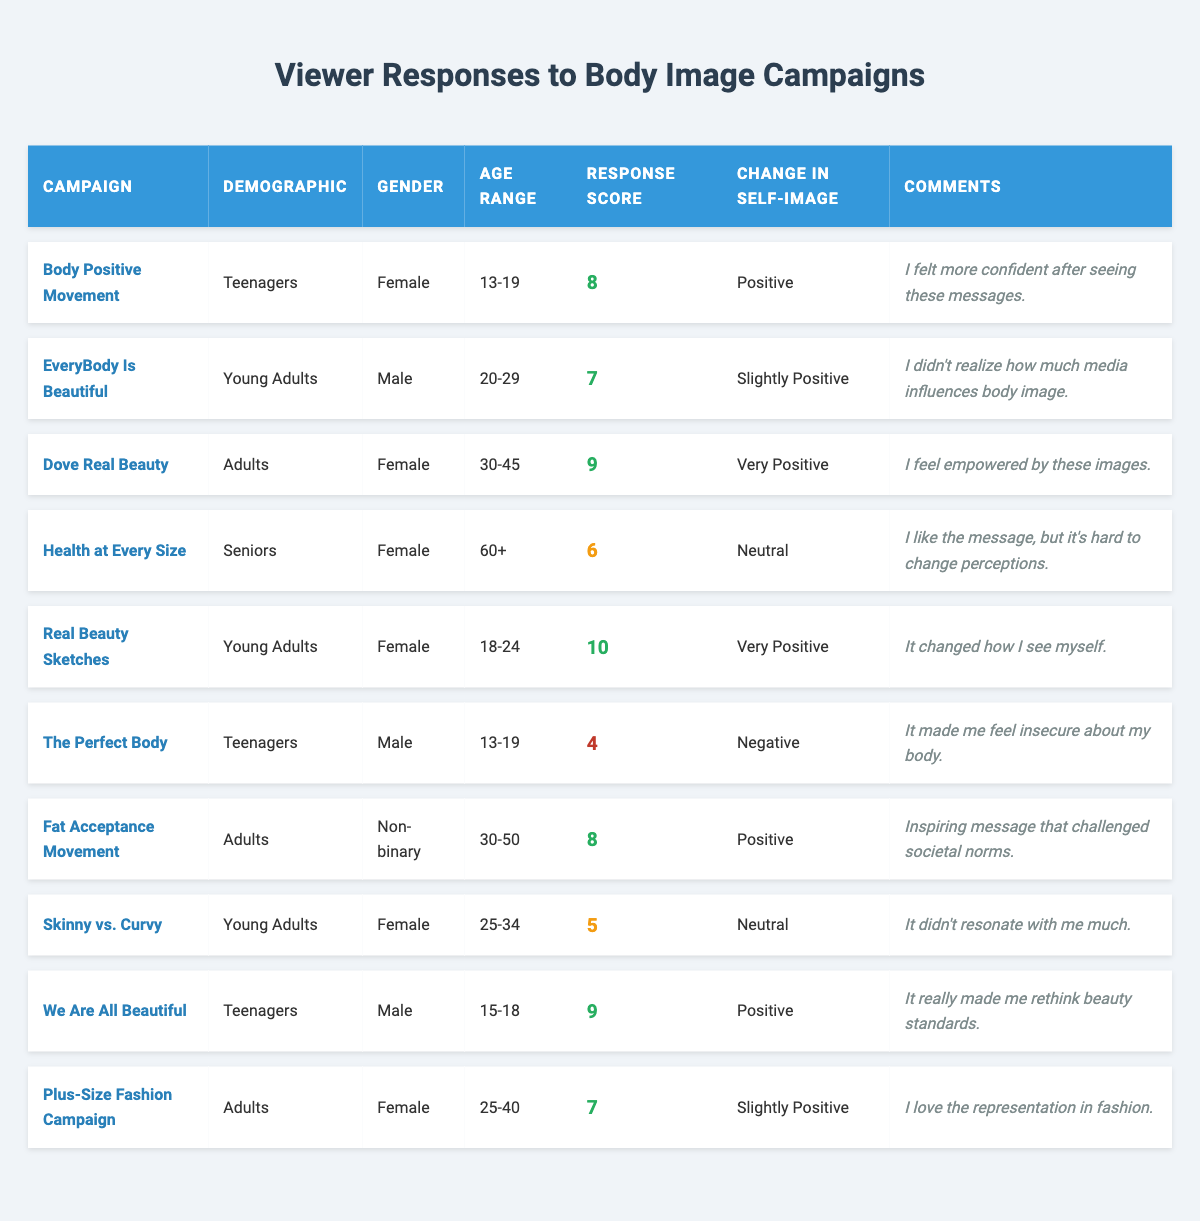What is the response score for the "Dove Real Beauty" campaign? To find the response score for the "Dove Real Beauty" campaign, locate it in the table and read the corresponding value under the "Response Score" column, which is 9.
Answer: 9 How many campaigns received a "Very Positive" change in self-image? By scanning the "Change in Self-Image" column for entries that say "Very Positive," we find that there are two campaigns: "Dove Real Beauty" and "Real Beauty Sketches."
Answer: 2 Which demographic showed the lowest response score, and what was the score? Looking through the "Response Score" column, the campaign "The Perfect Body" has the lowest score of 4, corresponding to the demographic "Teenagers."
Answer: Teenagers, 4 Is there any campaign that resulted in a "Negative" change in self-image? Check the "Change in Self-Image" column for the item indicating "Negative." The campaign "The Perfect Body" fits this criterion.
Answer: Yes How does the average response score for "Teenagers" compare to that of "Young Adults"? First, we gather the response scores for "Teenagers": 8 (Body Positive Movement) and 4 (The Perfect Body), giving a total of 12. The average for "Teenagers" is 12/2 = 6. For "Young Adults," the scores are 7 (EveryBody Is Beautiful), 10 (Real Beauty Sketches), and 5 (Skinny vs. Curvy), totaling 22. The average for "Young Adults" is 22/3 ≈ 7.33. The comparison shows that Young Adults have a higher average score.
Answer: Young Adults have a higher average score What percentage of campaigns targeting "Adults" resulted in a positive change in self-image? There are four campaigns targeting "Adults": "Dove Real Beauty" (Very Positive), "Fat Acceptance Movement" (Positive), and "Plus-Size Fashion Campaign" (Slightly Positive). Three of these campaigns show a positive change in self-image. To find the percentage, perform the calculation (3/4) * 100 = 75%.
Answer: 75% Among all demographics, which group's campaigns had the highest response score and what was it? Analyzing the response scores across all demographics, the "Real Beauty Sketches" campaign within "Young Adults" has the highest score of 10, making it the overall winner based on the data.
Answer: Young Adults, 10 How many campaigns were targeted towards "Seniors" and what was their average response score? There is 1 campaign for "Seniors," which is "Health at Every Size" with a score of 6. Since there's only one, the average is simply 6.
Answer: 1 campaign, average 6 Which gender had a campaign that resulted in a "Neutral" change in self-image? Looking at the "Change in Self-Image" column, the campaign "Skinny vs. Curvy" indicates "Neutral," and the gender associated is "Female."
Answer: Female 